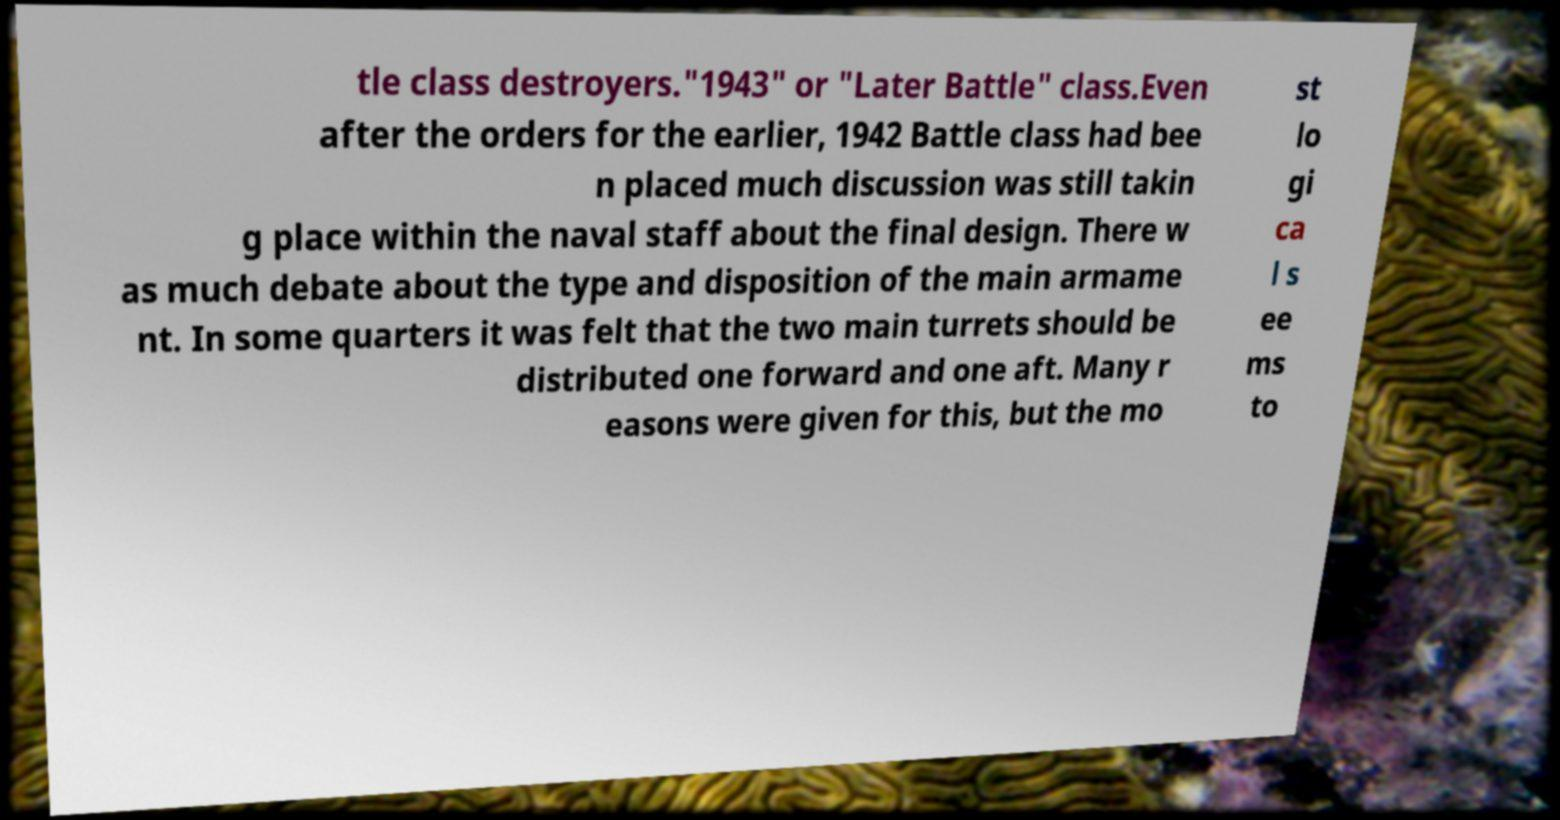Please read and relay the text visible in this image. What does it say? tle class destroyers."1943" or "Later Battle" class.Even after the orders for the earlier, 1942 Battle class had bee n placed much discussion was still takin g place within the naval staff about the final design. There w as much debate about the type and disposition of the main armame nt. In some quarters it was felt that the two main turrets should be distributed one forward and one aft. Many r easons were given for this, but the mo st lo gi ca l s ee ms to 